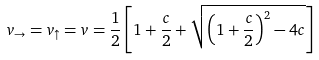<formula> <loc_0><loc_0><loc_500><loc_500>v _ { \rightarrow } = v _ { \uparrow } = v = \frac { 1 } { 2 } \left [ 1 + \frac { c } { 2 } + \sqrt { \left ( 1 + \frac { c } { 2 } \right ) ^ { 2 } - 4 c } \right ]</formula> 